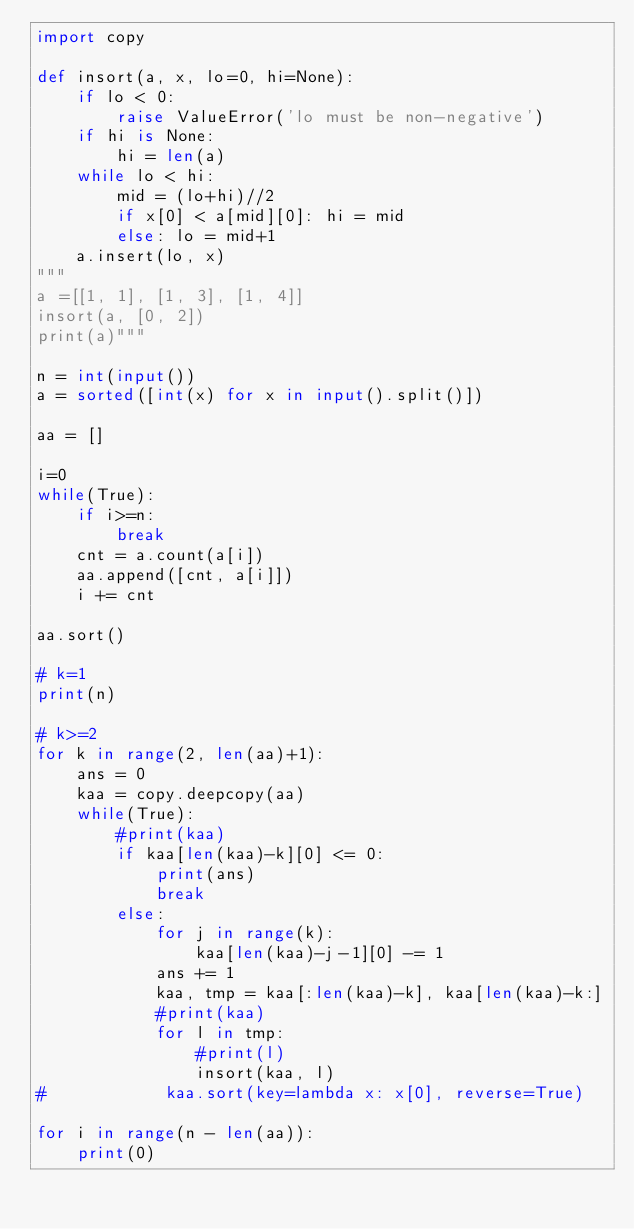<code> <loc_0><loc_0><loc_500><loc_500><_Python_>import copy

def insort(a, x, lo=0, hi=None):
    if lo < 0:
        raise ValueError('lo must be non-negative')
    if hi is None:
        hi = len(a)
    while lo < hi:
        mid = (lo+hi)//2
        if x[0] < a[mid][0]: hi = mid
        else: lo = mid+1
    a.insert(lo, x)
"""
a =[[1, 1], [1, 3], [1, 4]]
insort(a, [0, 2])
print(a)"""

n = int(input())
a = sorted([int(x) for x in input().split()])

aa = []

i=0
while(True):
    if i>=n:
        break
    cnt = a.count(a[i])
    aa.append([cnt, a[i]])
    i += cnt

aa.sort()

# k=1
print(n)

# k>=2
for k in range(2, len(aa)+1):
    ans = 0
    kaa = copy.deepcopy(aa)
    while(True):
        #print(kaa)
        if kaa[len(kaa)-k][0] <= 0:
            print(ans)
            break
        else:
            for j in range(k):
                kaa[len(kaa)-j-1][0] -= 1
            ans += 1
            kaa, tmp = kaa[:len(kaa)-k], kaa[len(kaa)-k:]
            #print(kaa)
            for l in tmp:
                #print(l)
                insort(kaa, l)
#            kaa.sort(key=lambda x: x[0], reverse=True)

for i in range(n - len(aa)):
    print(0)
</code> 